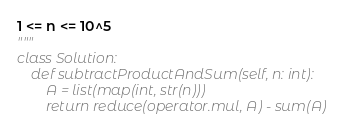<code> <loc_0><loc_0><loc_500><loc_500><_Python_>
1 <= n <= 10^5
"""
class Solution:
    def subtractProductAndSum(self, n: int):
        A = list(map(int, str(n)))
        return reduce(operator.mul, A) - sum(A)
</code> 